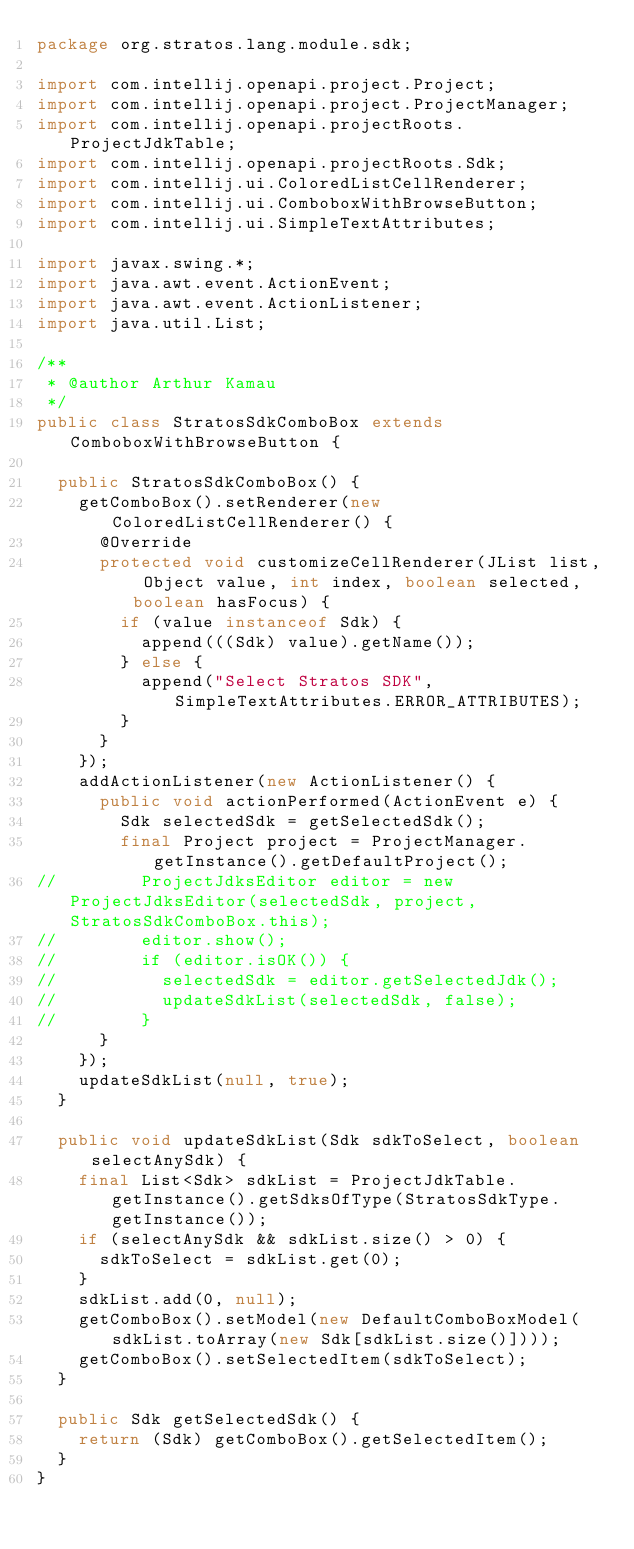Convert code to text. <code><loc_0><loc_0><loc_500><loc_500><_Java_>package org.stratos.lang.module.sdk;

import com.intellij.openapi.project.Project;
import com.intellij.openapi.project.ProjectManager;
import com.intellij.openapi.projectRoots.ProjectJdkTable;
import com.intellij.openapi.projectRoots.Sdk;
import com.intellij.ui.ColoredListCellRenderer;
import com.intellij.ui.ComboboxWithBrowseButton;
import com.intellij.ui.SimpleTextAttributes;

import javax.swing.*;
import java.awt.event.ActionEvent;
import java.awt.event.ActionListener;
import java.util.List;

/**
 * @author Arthur Kamau
 */
public class StratosSdkComboBox extends ComboboxWithBrowseButton {

  public StratosSdkComboBox() {
    getComboBox().setRenderer(new ColoredListCellRenderer() {
      @Override
      protected void customizeCellRenderer(JList list, Object value, int index, boolean selected, boolean hasFocus) {
        if (value instanceof Sdk) {
          append(((Sdk) value).getName());
        } else {
          append("Select Stratos SDK", SimpleTextAttributes.ERROR_ATTRIBUTES);
        }
      }
    });
    addActionListener(new ActionListener() {
      public void actionPerformed(ActionEvent e) {
        Sdk selectedSdk = getSelectedSdk();
        final Project project = ProjectManager.getInstance().getDefaultProject();
//        ProjectJdksEditor editor = new ProjectJdksEditor(selectedSdk, project, StratosSdkComboBox.this);
//        editor.show();
//        if (editor.isOK()) {
//          selectedSdk = editor.getSelectedJdk();
//          updateSdkList(selectedSdk, false);
//        }
      }
    });
    updateSdkList(null, true);
  }

  public void updateSdkList(Sdk sdkToSelect, boolean selectAnySdk) {
    final List<Sdk> sdkList = ProjectJdkTable.getInstance().getSdksOfType(StratosSdkType.getInstance());
    if (selectAnySdk && sdkList.size() > 0) {
      sdkToSelect = sdkList.get(0);
    }
    sdkList.add(0, null);
    getComboBox().setModel(new DefaultComboBoxModel(sdkList.toArray(new Sdk[sdkList.size()])));
    getComboBox().setSelectedItem(sdkToSelect);
  }

  public Sdk getSelectedSdk() {
    return (Sdk) getComboBox().getSelectedItem();
  }
}
</code> 